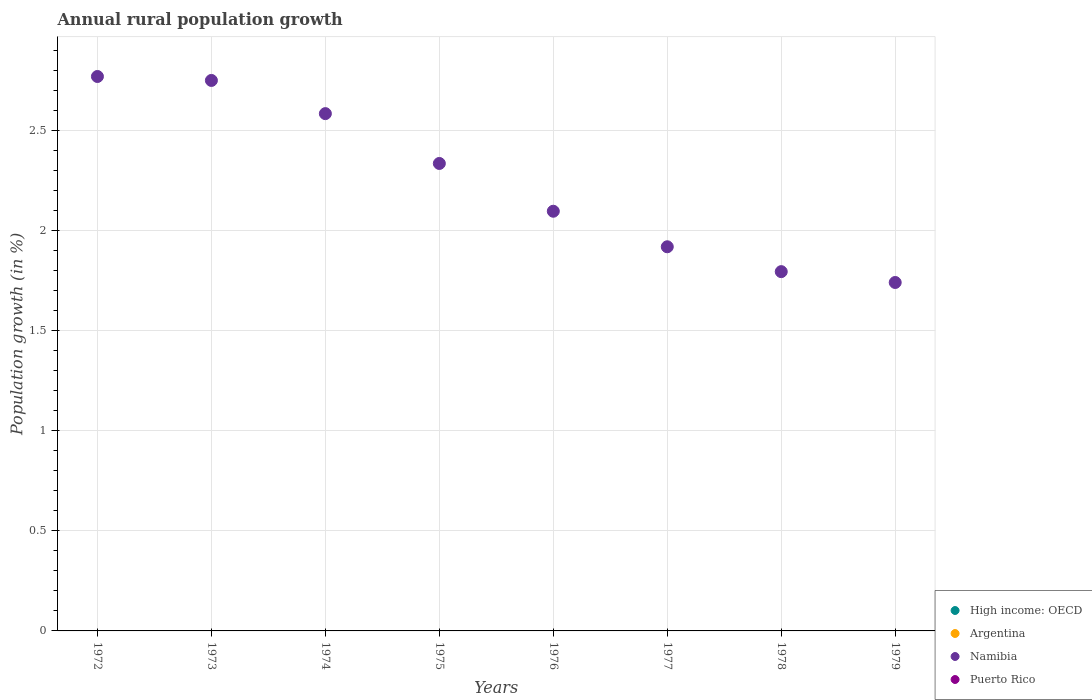How many different coloured dotlines are there?
Your response must be concise. 1. What is the percentage of rural population growth in Puerto Rico in 1973?
Keep it short and to the point. 0. Across all years, what is the maximum percentage of rural population growth in Namibia?
Your response must be concise. 2.77. Across all years, what is the minimum percentage of rural population growth in Namibia?
Provide a short and direct response. 1.74. What is the total percentage of rural population growth in Namibia in the graph?
Your response must be concise. 18. What is the difference between the percentage of rural population growth in Namibia in 1974 and that in 1976?
Ensure brevity in your answer.  0.49. What is the difference between the percentage of rural population growth in Argentina in 1979 and the percentage of rural population growth in High income: OECD in 1975?
Give a very brief answer. 0. What is the average percentage of rural population growth in High income: OECD per year?
Make the answer very short. 0. In how many years, is the percentage of rural population growth in High income: OECD greater than 0.1 %?
Offer a very short reply. 0. What is the ratio of the percentage of rural population growth in Namibia in 1974 to that in 1979?
Provide a short and direct response. 1.48. What is the difference between the highest and the lowest percentage of rural population growth in Namibia?
Offer a terse response. 1.03. In how many years, is the percentage of rural population growth in Namibia greater than the average percentage of rural population growth in Namibia taken over all years?
Your answer should be compact. 4. Is it the case that in every year, the sum of the percentage of rural population growth in Namibia and percentage of rural population growth in Argentina  is greater than the sum of percentage of rural population growth in High income: OECD and percentage of rural population growth in Puerto Rico?
Your answer should be compact. Yes. Is it the case that in every year, the sum of the percentage of rural population growth in Puerto Rico and percentage of rural population growth in High income: OECD  is greater than the percentage of rural population growth in Argentina?
Make the answer very short. No. Does the percentage of rural population growth in High income: OECD monotonically increase over the years?
Your answer should be compact. No. How many dotlines are there?
Ensure brevity in your answer.  1. How many years are there in the graph?
Make the answer very short. 8. Are the values on the major ticks of Y-axis written in scientific E-notation?
Offer a terse response. No. Does the graph contain any zero values?
Give a very brief answer. Yes. How many legend labels are there?
Offer a terse response. 4. What is the title of the graph?
Provide a short and direct response. Annual rural population growth. Does "Ecuador" appear as one of the legend labels in the graph?
Ensure brevity in your answer.  No. What is the label or title of the X-axis?
Your answer should be compact. Years. What is the label or title of the Y-axis?
Offer a terse response. Population growth (in %). What is the Population growth (in %) in High income: OECD in 1972?
Make the answer very short. 0. What is the Population growth (in %) in Argentina in 1972?
Offer a very short reply. 0. What is the Population growth (in %) in Namibia in 1972?
Your answer should be compact. 2.77. What is the Population growth (in %) in Namibia in 1973?
Your answer should be very brief. 2.75. What is the Population growth (in %) of Puerto Rico in 1973?
Your answer should be compact. 0. What is the Population growth (in %) of Namibia in 1974?
Provide a short and direct response. 2.59. What is the Population growth (in %) of Argentina in 1975?
Ensure brevity in your answer.  0. What is the Population growth (in %) in Namibia in 1975?
Ensure brevity in your answer.  2.34. What is the Population growth (in %) in Puerto Rico in 1975?
Offer a very short reply. 0. What is the Population growth (in %) in High income: OECD in 1976?
Provide a short and direct response. 0. What is the Population growth (in %) in Argentina in 1976?
Give a very brief answer. 0. What is the Population growth (in %) of Namibia in 1976?
Offer a terse response. 2.1. What is the Population growth (in %) in High income: OECD in 1977?
Offer a very short reply. 0. What is the Population growth (in %) in Argentina in 1977?
Offer a terse response. 0. What is the Population growth (in %) in Namibia in 1977?
Offer a very short reply. 1.92. What is the Population growth (in %) of Argentina in 1978?
Keep it short and to the point. 0. What is the Population growth (in %) of Namibia in 1978?
Keep it short and to the point. 1.8. What is the Population growth (in %) in High income: OECD in 1979?
Keep it short and to the point. 0. What is the Population growth (in %) in Namibia in 1979?
Your response must be concise. 1.74. Across all years, what is the maximum Population growth (in %) in Namibia?
Make the answer very short. 2.77. Across all years, what is the minimum Population growth (in %) in Namibia?
Offer a very short reply. 1.74. What is the total Population growth (in %) in Argentina in the graph?
Ensure brevity in your answer.  0. What is the total Population growth (in %) in Namibia in the graph?
Offer a terse response. 18. What is the total Population growth (in %) in Puerto Rico in the graph?
Keep it short and to the point. 0. What is the difference between the Population growth (in %) of Namibia in 1972 and that in 1973?
Offer a very short reply. 0.02. What is the difference between the Population growth (in %) in Namibia in 1972 and that in 1974?
Provide a succinct answer. 0.19. What is the difference between the Population growth (in %) of Namibia in 1972 and that in 1975?
Your response must be concise. 0.43. What is the difference between the Population growth (in %) in Namibia in 1972 and that in 1976?
Your response must be concise. 0.67. What is the difference between the Population growth (in %) in Namibia in 1972 and that in 1977?
Keep it short and to the point. 0.85. What is the difference between the Population growth (in %) of Namibia in 1972 and that in 1978?
Your response must be concise. 0.98. What is the difference between the Population growth (in %) of Namibia in 1972 and that in 1979?
Offer a terse response. 1.03. What is the difference between the Population growth (in %) of Namibia in 1973 and that in 1974?
Provide a short and direct response. 0.17. What is the difference between the Population growth (in %) in Namibia in 1973 and that in 1975?
Offer a terse response. 0.41. What is the difference between the Population growth (in %) of Namibia in 1973 and that in 1976?
Keep it short and to the point. 0.65. What is the difference between the Population growth (in %) of Namibia in 1973 and that in 1977?
Offer a very short reply. 0.83. What is the difference between the Population growth (in %) of Namibia in 1973 and that in 1978?
Give a very brief answer. 0.96. What is the difference between the Population growth (in %) in Namibia in 1973 and that in 1979?
Keep it short and to the point. 1.01. What is the difference between the Population growth (in %) of Namibia in 1974 and that in 1975?
Your answer should be compact. 0.25. What is the difference between the Population growth (in %) of Namibia in 1974 and that in 1976?
Your response must be concise. 0.49. What is the difference between the Population growth (in %) of Namibia in 1974 and that in 1977?
Provide a short and direct response. 0.67. What is the difference between the Population growth (in %) of Namibia in 1974 and that in 1978?
Provide a short and direct response. 0.79. What is the difference between the Population growth (in %) in Namibia in 1974 and that in 1979?
Keep it short and to the point. 0.84. What is the difference between the Population growth (in %) of Namibia in 1975 and that in 1976?
Provide a succinct answer. 0.24. What is the difference between the Population growth (in %) in Namibia in 1975 and that in 1977?
Your answer should be compact. 0.42. What is the difference between the Population growth (in %) in Namibia in 1975 and that in 1978?
Your answer should be very brief. 0.54. What is the difference between the Population growth (in %) of Namibia in 1975 and that in 1979?
Ensure brevity in your answer.  0.59. What is the difference between the Population growth (in %) of Namibia in 1976 and that in 1977?
Provide a succinct answer. 0.18. What is the difference between the Population growth (in %) of Namibia in 1976 and that in 1978?
Ensure brevity in your answer.  0.3. What is the difference between the Population growth (in %) in Namibia in 1976 and that in 1979?
Provide a succinct answer. 0.36. What is the difference between the Population growth (in %) of Namibia in 1977 and that in 1978?
Your answer should be compact. 0.12. What is the difference between the Population growth (in %) of Namibia in 1977 and that in 1979?
Give a very brief answer. 0.18. What is the difference between the Population growth (in %) of Namibia in 1978 and that in 1979?
Provide a succinct answer. 0.05. What is the average Population growth (in %) of High income: OECD per year?
Give a very brief answer. 0. What is the average Population growth (in %) of Argentina per year?
Offer a terse response. 0. What is the average Population growth (in %) in Namibia per year?
Make the answer very short. 2.25. What is the average Population growth (in %) of Puerto Rico per year?
Provide a succinct answer. 0. What is the ratio of the Population growth (in %) of Namibia in 1972 to that in 1973?
Keep it short and to the point. 1.01. What is the ratio of the Population growth (in %) in Namibia in 1972 to that in 1974?
Give a very brief answer. 1.07. What is the ratio of the Population growth (in %) of Namibia in 1972 to that in 1975?
Give a very brief answer. 1.19. What is the ratio of the Population growth (in %) in Namibia in 1972 to that in 1976?
Keep it short and to the point. 1.32. What is the ratio of the Population growth (in %) of Namibia in 1972 to that in 1977?
Your answer should be compact. 1.44. What is the ratio of the Population growth (in %) of Namibia in 1972 to that in 1978?
Make the answer very short. 1.54. What is the ratio of the Population growth (in %) in Namibia in 1972 to that in 1979?
Your answer should be very brief. 1.59. What is the ratio of the Population growth (in %) in Namibia in 1973 to that in 1974?
Offer a very short reply. 1.06. What is the ratio of the Population growth (in %) in Namibia in 1973 to that in 1975?
Ensure brevity in your answer.  1.18. What is the ratio of the Population growth (in %) in Namibia in 1973 to that in 1976?
Make the answer very short. 1.31. What is the ratio of the Population growth (in %) in Namibia in 1973 to that in 1977?
Provide a short and direct response. 1.43. What is the ratio of the Population growth (in %) of Namibia in 1973 to that in 1978?
Offer a very short reply. 1.53. What is the ratio of the Population growth (in %) of Namibia in 1973 to that in 1979?
Your answer should be compact. 1.58. What is the ratio of the Population growth (in %) in Namibia in 1974 to that in 1975?
Your response must be concise. 1.11. What is the ratio of the Population growth (in %) in Namibia in 1974 to that in 1976?
Give a very brief answer. 1.23. What is the ratio of the Population growth (in %) in Namibia in 1974 to that in 1977?
Give a very brief answer. 1.35. What is the ratio of the Population growth (in %) of Namibia in 1974 to that in 1978?
Your answer should be compact. 1.44. What is the ratio of the Population growth (in %) in Namibia in 1974 to that in 1979?
Ensure brevity in your answer.  1.48. What is the ratio of the Population growth (in %) in Namibia in 1975 to that in 1976?
Make the answer very short. 1.11. What is the ratio of the Population growth (in %) in Namibia in 1975 to that in 1977?
Provide a short and direct response. 1.22. What is the ratio of the Population growth (in %) of Namibia in 1975 to that in 1978?
Ensure brevity in your answer.  1.3. What is the ratio of the Population growth (in %) in Namibia in 1975 to that in 1979?
Offer a very short reply. 1.34. What is the ratio of the Population growth (in %) in Namibia in 1976 to that in 1977?
Ensure brevity in your answer.  1.09. What is the ratio of the Population growth (in %) of Namibia in 1976 to that in 1978?
Your response must be concise. 1.17. What is the ratio of the Population growth (in %) of Namibia in 1976 to that in 1979?
Your response must be concise. 1.2. What is the ratio of the Population growth (in %) in Namibia in 1977 to that in 1978?
Provide a short and direct response. 1.07. What is the ratio of the Population growth (in %) of Namibia in 1977 to that in 1979?
Offer a terse response. 1.1. What is the ratio of the Population growth (in %) of Namibia in 1978 to that in 1979?
Offer a very short reply. 1.03. What is the difference between the highest and the second highest Population growth (in %) of Namibia?
Ensure brevity in your answer.  0.02. What is the difference between the highest and the lowest Population growth (in %) of Namibia?
Provide a short and direct response. 1.03. 